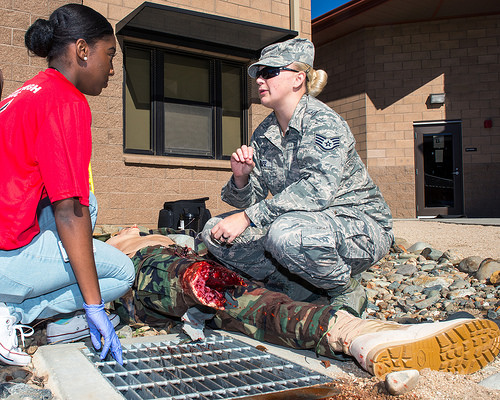<image>
Can you confirm if the woman is behind the woman? No. The woman is not behind the woman. From this viewpoint, the woman appears to be positioned elsewhere in the scene. 